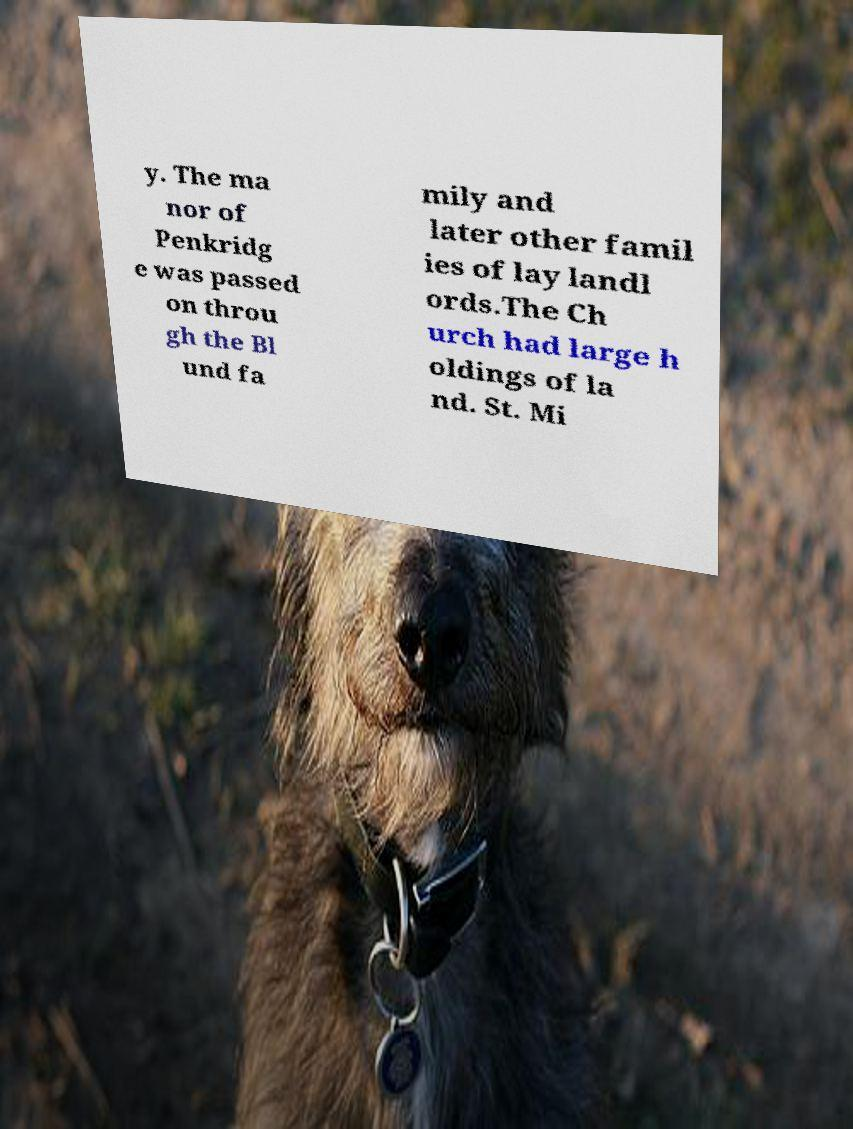There's text embedded in this image that I need extracted. Can you transcribe it verbatim? y. The ma nor of Penkridg e was passed on throu gh the Bl und fa mily and later other famil ies of lay landl ords.The Ch urch had large h oldings of la nd. St. Mi 